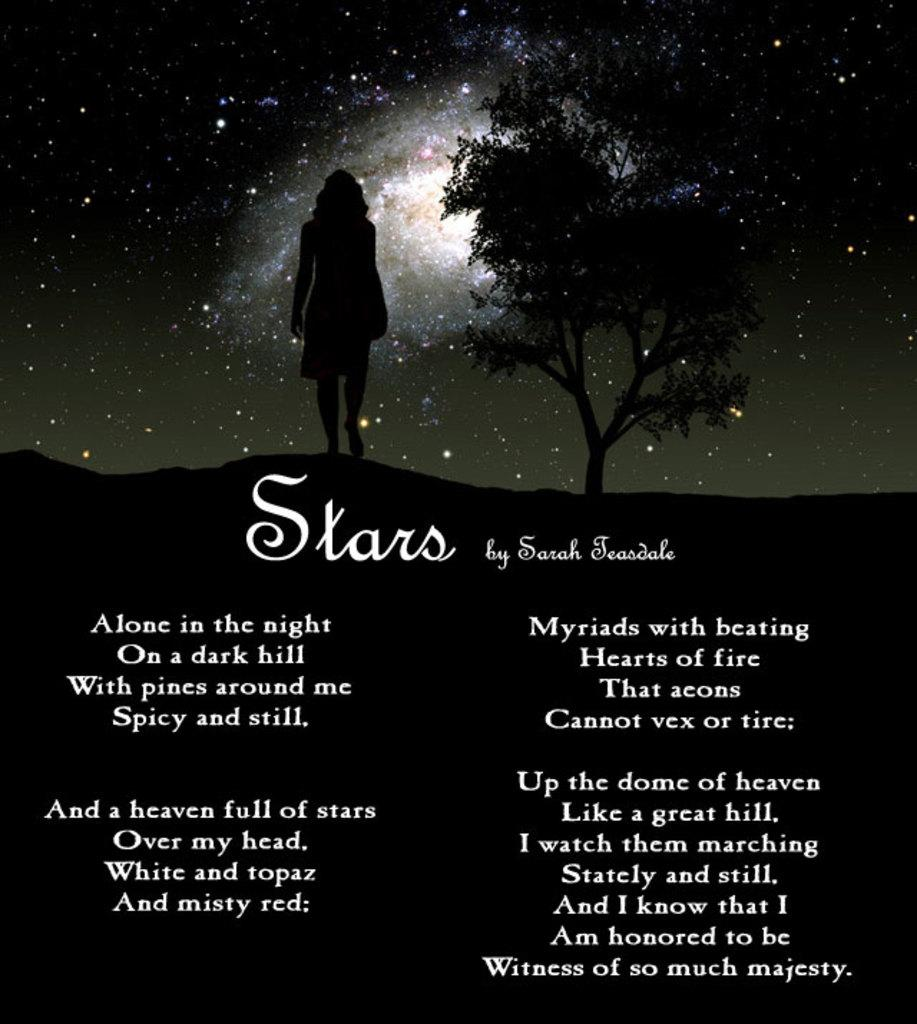What is written on the image? There is a poem written on the image. Can you describe the background of the image? There is a woman and a tree in the background of the image, along with the sky. What celestial bodies are visible in the sky? Stars and the moon are present in the sky. What type of angle is the kitty using to climb the tree in the image? There is no kitty present in the image, so it is not possible to determine the angle it might use to climb a tree. 